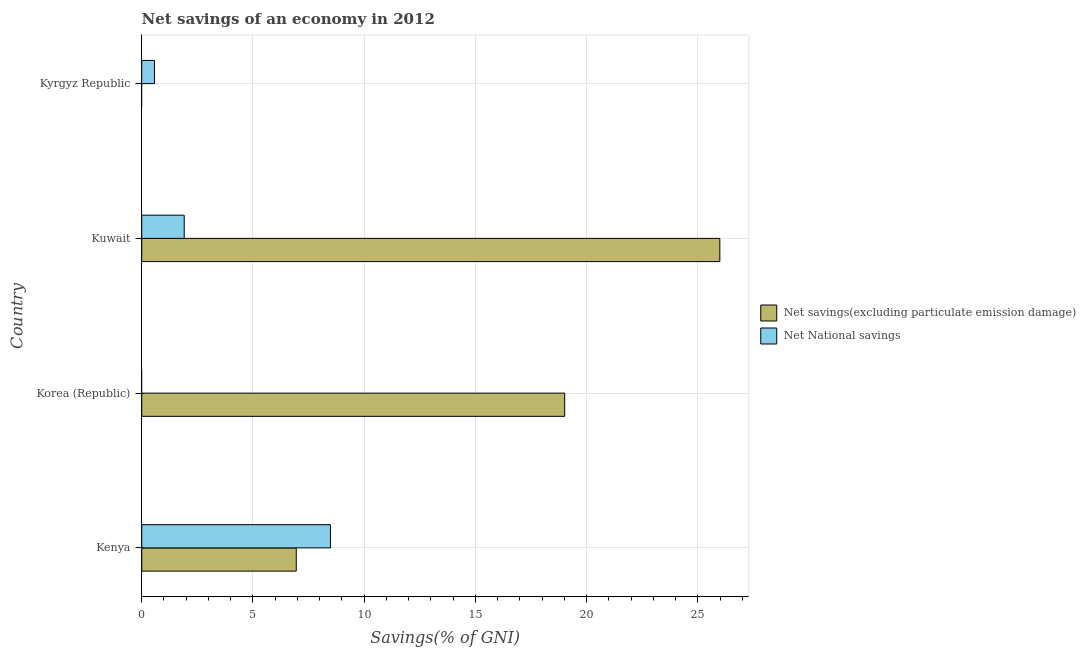Are the number of bars per tick equal to the number of legend labels?
Provide a succinct answer. No. Are the number of bars on each tick of the Y-axis equal?
Make the answer very short. No. How many bars are there on the 1st tick from the top?
Ensure brevity in your answer.  1. How many bars are there on the 3rd tick from the bottom?
Offer a terse response. 2. What is the label of the 1st group of bars from the top?
Keep it short and to the point. Kyrgyz Republic. What is the net savings(excluding particulate emission damage) in Kuwait?
Offer a terse response. 25.99. Across all countries, what is the maximum net savings(excluding particulate emission damage)?
Your answer should be very brief. 25.99. In which country was the net national savings maximum?
Offer a very short reply. Kenya. What is the total net national savings in the graph?
Provide a succinct answer. 10.97. What is the difference between the net savings(excluding particulate emission damage) in Kenya and that in Korea (Republic)?
Make the answer very short. -12.06. What is the difference between the net savings(excluding particulate emission damage) in Kenya and the net national savings in Kyrgyz Republic?
Provide a short and direct response. 6.37. What is the average net savings(excluding particulate emission damage) per country?
Keep it short and to the point. 12.99. What is the difference between the net savings(excluding particulate emission damage) and net national savings in Kenya?
Ensure brevity in your answer.  -1.54. What is the ratio of the net national savings in Kenya to that in Kuwait?
Provide a succinct answer. 4.44. Is the net savings(excluding particulate emission damage) in Kenya less than that in Kuwait?
Ensure brevity in your answer.  Yes. What is the difference between the highest and the second highest net savings(excluding particulate emission damage)?
Give a very brief answer. 6.97. What is the difference between the highest and the lowest net savings(excluding particulate emission damage)?
Give a very brief answer. 25.99. In how many countries, is the net national savings greater than the average net national savings taken over all countries?
Your response must be concise. 1. Is the sum of the net national savings in Kuwait and Kyrgyz Republic greater than the maximum net savings(excluding particulate emission damage) across all countries?
Make the answer very short. No. Where does the legend appear in the graph?
Provide a short and direct response. Center right. What is the title of the graph?
Offer a very short reply. Net savings of an economy in 2012. What is the label or title of the X-axis?
Ensure brevity in your answer.  Savings(% of GNI). What is the Savings(% of GNI) of Net savings(excluding particulate emission damage) in Kenya?
Your response must be concise. 6.95. What is the Savings(% of GNI) in Net National savings in Kenya?
Make the answer very short. 8.48. What is the Savings(% of GNI) of Net savings(excluding particulate emission damage) in Korea (Republic)?
Offer a terse response. 19.01. What is the Savings(% of GNI) of Net savings(excluding particulate emission damage) in Kuwait?
Provide a succinct answer. 25.99. What is the Savings(% of GNI) of Net National savings in Kuwait?
Provide a succinct answer. 1.91. What is the Savings(% of GNI) of Net National savings in Kyrgyz Republic?
Ensure brevity in your answer.  0.57. Across all countries, what is the maximum Savings(% of GNI) in Net savings(excluding particulate emission damage)?
Your answer should be compact. 25.99. Across all countries, what is the maximum Savings(% of GNI) of Net National savings?
Provide a short and direct response. 8.48. What is the total Savings(% of GNI) of Net savings(excluding particulate emission damage) in the graph?
Your answer should be compact. 51.95. What is the total Savings(% of GNI) of Net National savings in the graph?
Your answer should be compact. 10.97. What is the difference between the Savings(% of GNI) in Net savings(excluding particulate emission damage) in Kenya and that in Korea (Republic)?
Offer a very short reply. -12.07. What is the difference between the Savings(% of GNI) in Net savings(excluding particulate emission damage) in Kenya and that in Kuwait?
Provide a succinct answer. -19.04. What is the difference between the Savings(% of GNI) of Net National savings in Kenya and that in Kuwait?
Keep it short and to the point. 6.57. What is the difference between the Savings(% of GNI) of Net National savings in Kenya and that in Kyrgyz Republic?
Ensure brevity in your answer.  7.91. What is the difference between the Savings(% of GNI) of Net savings(excluding particulate emission damage) in Korea (Republic) and that in Kuwait?
Offer a terse response. -6.98. What is the difference between the Savings(% of GNI) of Net National savings in Kuwait and that in Kyrgyz Republic?
Your response must be concise. 1.34. What is the difference between the Savings(% of GNI) of Net savings(excluding particulate emission damage) in Kenya and the Savings(% of GNI) of Net National savings in Kuwait?
Your response must be concise. 5.04. What is the difference between the Savings(% of GNI) of Net savings(excluding particulate emission damage) in Kenya and the Savings(% of GNI) of Net National savings in Kyrgyz Republic?
Ensure brevity in your answer.  6.37. What is the difference between the Savings(% of GNI) in Net savings(excluding particulate emission damage) in Korea (Republic) and the Savings(% of GNI) in Net National savings in Kuwait?
Ensure brevity in your answer.  17.1. What is the difference between the Savings(% of GNI) in Net savings(excluding particulate emission damage) in Korea (Republic) and the Savings(% of GNI) in Net National savings in Kyrgyz Republic?
Give a very brief answer. 18.44. What is the difference between the Savings(% of GNI) of Net savings(excluding particulate emission damage) in Kuwait and the Savings(% of GNI) of Net National savings in Kyrgyz Republic?
Your answer should be compact. 25.42. What is the average Savings(% of GNI) of Net savings(excluding particulate emission damage) per country?
Offer a terse response. 12.99. What is the average Savings(% of GNI) in Net National savings per country?
Your answer should be compact. 2.74. What is the difference between the Savings(% of GNI) in Net savings(excluding particulate emission damage) and Savings(% of GNI) in Net National savings in Kenya?
Give a very brief answer. -1.54. What is the difference between the Savings(% of GNI) in Net savings(excluding particulate emission damage) and Savings(% of GNI) in Net National savings in Kuwait?
Make the answer very short. 24.08. What is the ratio of the Savings(% of GNI) in Net savings(excluding particulate emission damage) in Kenya to that in Korea (Republic)?
Your answer should be compact. 0.37. What is the ratio of the Savings(% of GNI) of Net savings(excluding particulate emission damage) in Kenya to that in Kuwait?
Keep it short and to the point. 0.27. What is the ratio of the Savings(% of GNI) of Net National savings in Kenya to that in Kuwait?
Give a very brief answer. 4.44. What is the ratio of the Savings(% of GNI) in Net National savings in Kenya to that in Kyrgyz Republic?
Ensure brevity in your answer.  14.81. What is the ratio of the Savings(% of GNI) of Net savings(excluding particulate emission damage) in Korea (Republic) to that in Kuwait?
Provide a succinct answer. 0.73. What is the ratio of the Savings(% of GNI) of Net National savings in Kuwait to that in Kyrgyz Republic?
Your response must be concise. 3.33. What is the difference between the highest and the second highest Savings(% of GNI) in Net savings(excluding particulate emission damage)?
Keep it short and to the point. 6.98. What is the difference between the highest and the second highest Savings(% of GNI) in Net National savings?
Ensure brevity in your answer.  6.57. What is the difference between the highest and the lowest Savings(% of GNI) in Net savings(excluding particulate emission damage)?
Provide a short and direct response. 25.99. What is the difference between the highest and the lowest Savings(% of GNI) in Net National savings?
Offer a terse response. 8.48. 